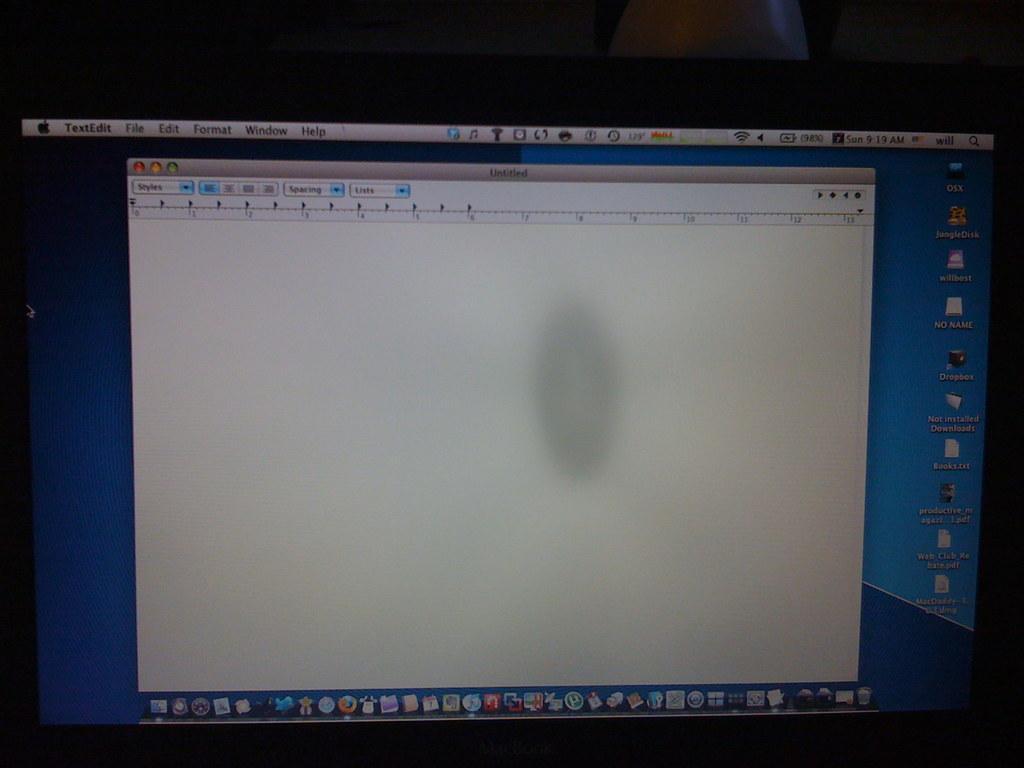Please provide a concise description of this image. In this image, I can see a screen. On the screen, there are icons, words and a menu bar. 